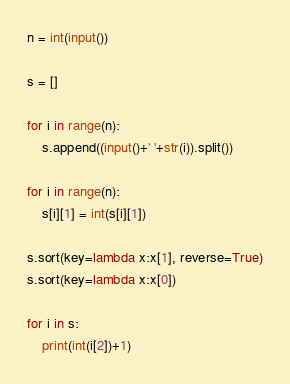Convert code to text. <code><loc_0><loc_0><loc_500><loc_500><_Python_>n = int(input())

s = []

for i in range(n):
	s.append((input()+' '+str(i)).split())

for i in range(n):
	s[i][1] = int(s[i][1])
    
s.sort(key=lambda x:x[1], reverse=True)
s.sort(key=lambda x:x[0])

for i in s:
	print(int(i[2])+1)</code> 